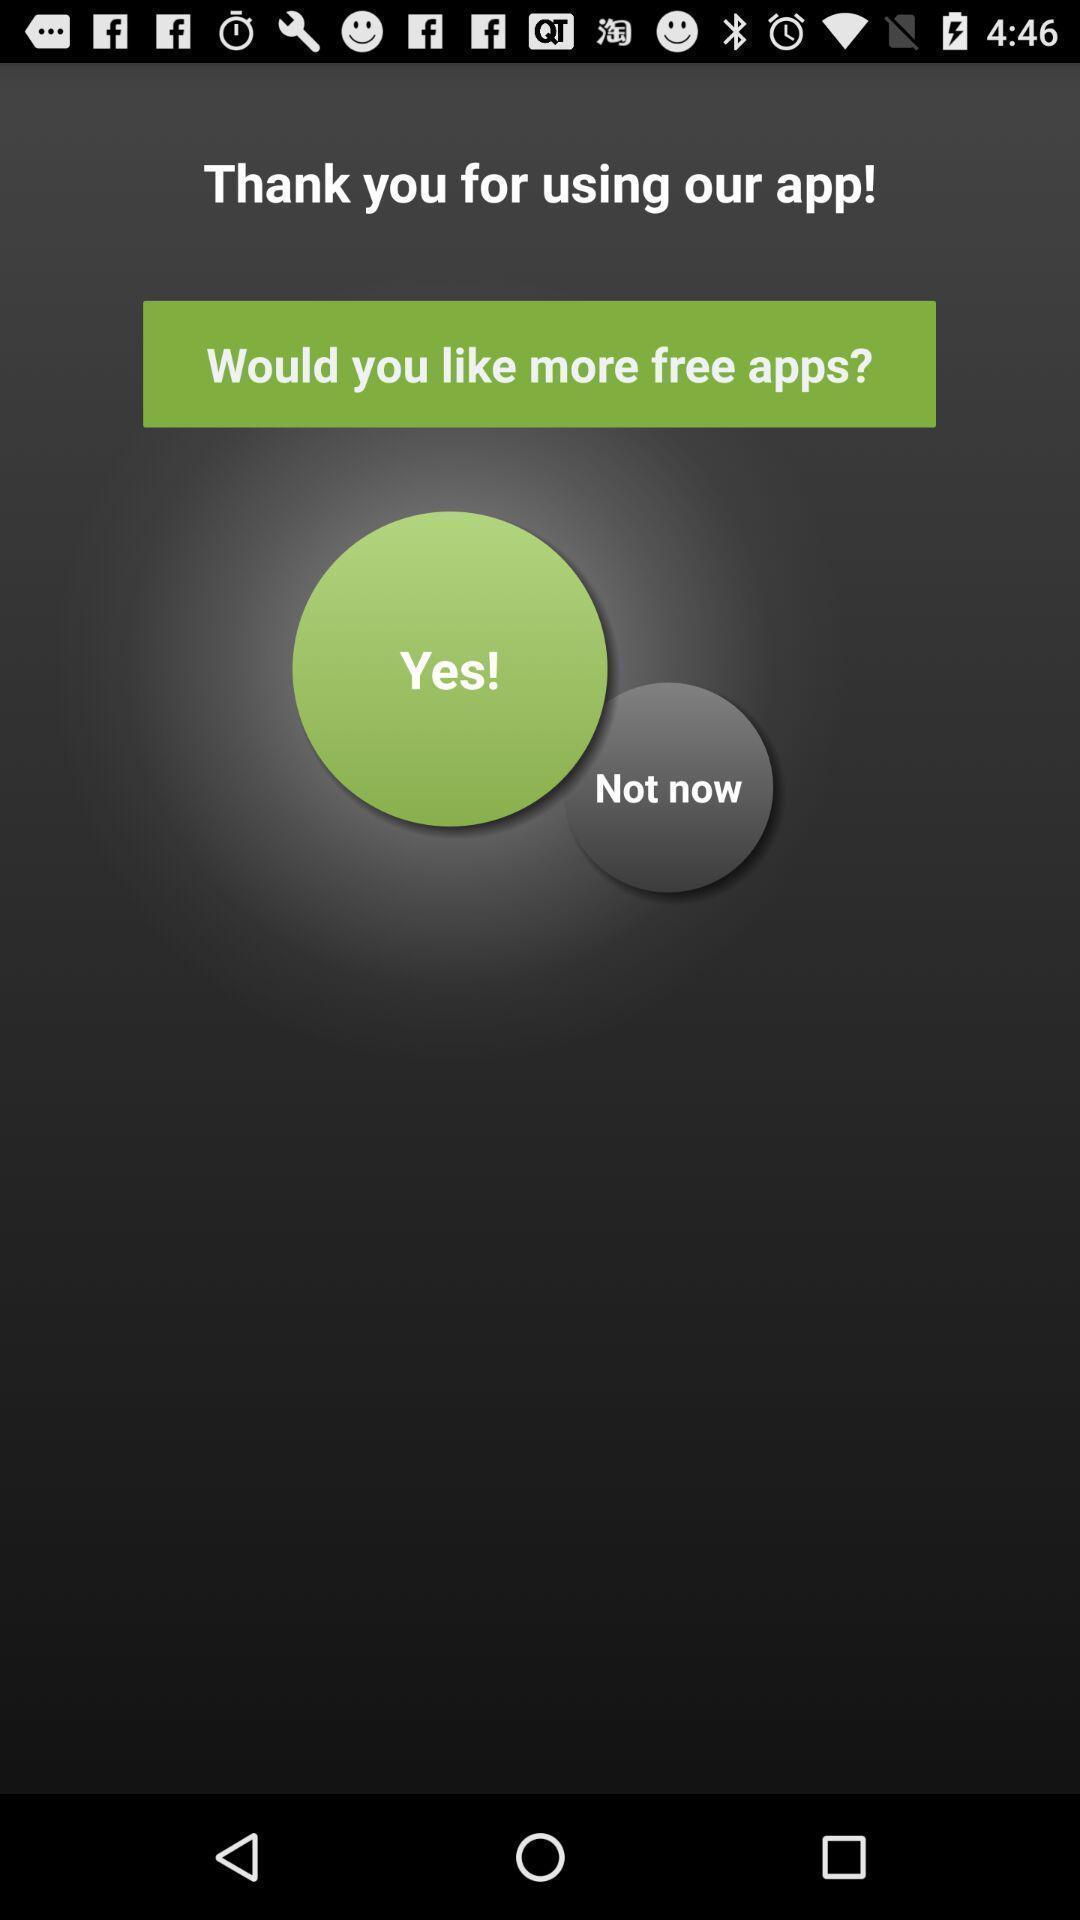Summarize the main components in this picture. Yes or not now option for using free apps. 